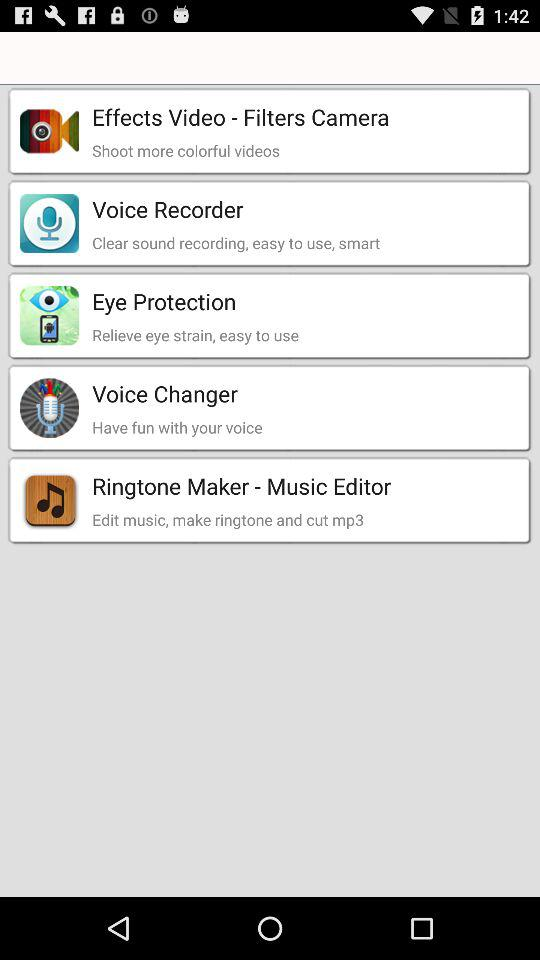Which app can we use to relieve eye strain? You can use "Eye Protection" to relieve eye strain. 